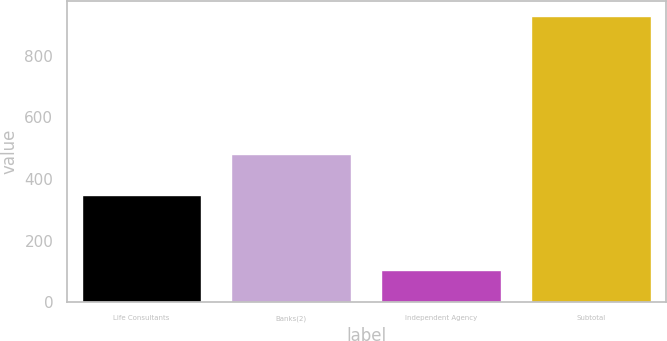Convert chart. <chart><loc_0><loc_0><loc_500><loc_500><bar_chart><fcel>Life Consultants<fcel>Banks(2)<fcel>Independent Agency<fcel>Subtotal<nl><fcel>347<fcel>480<fcel>104<fcel>931<nl></chart> 